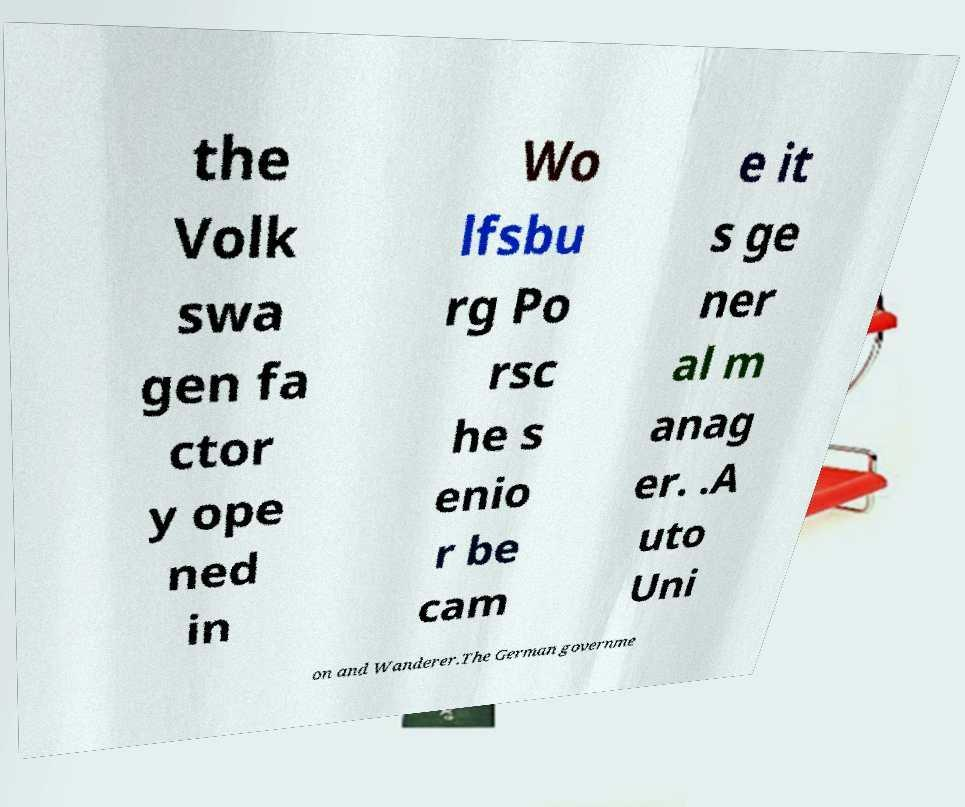For documentation purposes, I need the text within this image transcribed. Could you provide that? the Volk swa gen fa ctor y ope ned in Wo lfsbu rg Po rsc he s enio r be cam e it s ge ner al m anag er. .A uto Uni on and Wanderer.The German governme 